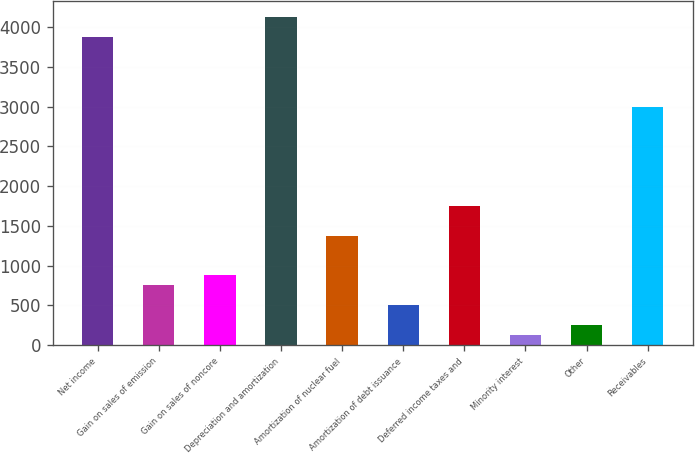Convert chart. <chart><loc_0><loc_0><loc_500><loc_500><bar_chart><fcel>Net income<fcel>Gain on sales of emission<fcel>Gain on sales of noncore<fcel>Depreciation and amortization<fcel>Amortization of nuclear fuel<fcel>Amortization of debt issuance<fcel>Deferred income taxes and<fcel>Minority interest<fcel>Other<fcel>Receivables<nl><fcel>3876<fcel>751<fcel>876<fcel>4126<fcel>1376<fcel>501<fcel>1751<fcel>126<fcel>251<fcel>3001<nl></chart> 